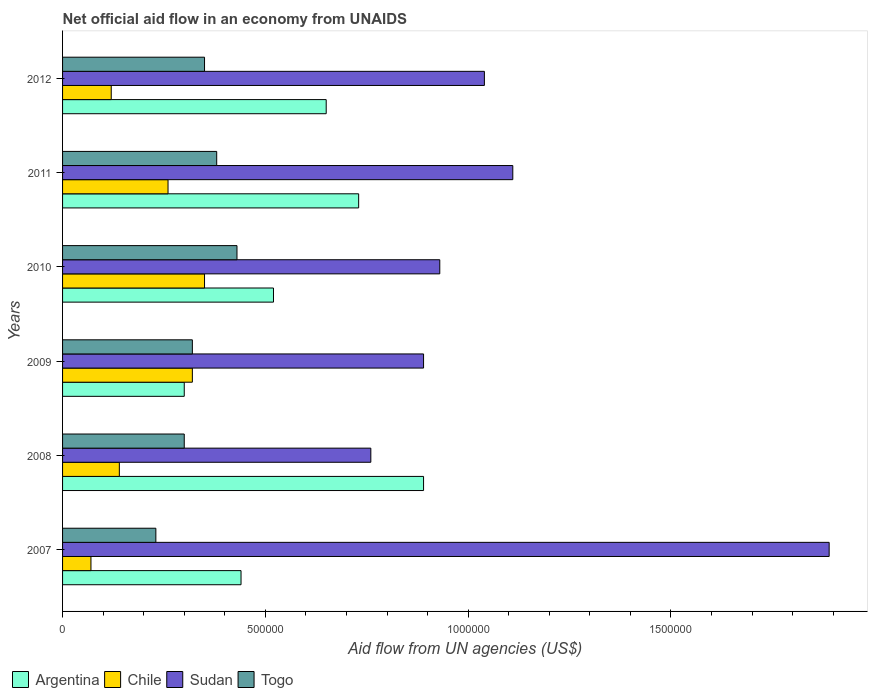How many different coloured bars are there?
Offer a very short reply. 4. Are the number of bars per tick equal to the number of legend labels?
Your answer should be compact. Yes. Are the number of bars on each tick of the Y-axis equal?
Keep it short and to the point. Yes. What is the net official aid flow in Chile in 2011?
Your answer should be compact. 2.60e+05. Across all years, what is the maximum net official aid flow in Argentina?
Ensure brevity in your answer.  8.90e+05. Across all years, what is the minimum net official aid flow in Sudan?
Provide a succinct answer. 7.60e+05. In which year was the net official aid flow in Togo maximum?
Your answer should be very brief. 2010. What is the total net official aid flow in Togo in the graph?
Keep it short and to the point. 2.01e+06. What is the difference between the net official aid flow in Argentina in 2009 and that in 2012?
Keep it short and to the point. -3.50e+05. What is the difference between the net official aid flow in Togo in 2007 and the net official aid flow in Chile in 2012?
Your answer should be very brief. 1.10e+05. What is the average net official aid flow in Sudan per year?
Offer a terse response. 1.10e+06. In the year 2011, what is the difference between the net official aid flow in Togo and net official aid flow in Chile?
Keep it short and to the point. 1.20e+05. In how many years, is the net official aid flow in Sudan greater than 1600000 US$?
Make the answer very short. 1. What is the ratio of the net official aid flow in Togo in 2007 to that in 2009?
Your answer should be very brief. 0.72. Is the difference between the net official aid flow in Togo in 2010 and 2011 greater than the difference between the net official aid flow in Chile in 2010 and 2011?
Make the answer very short. No. What is the difference between the highest and the second highest net official aid flow in Argentina?
Offer a terse response. 1.60e+05. What is the difference between the highest and the lowest net official aid flow in Chile?
Keep it short and to the point. 2.80e+05. In how many years, is the net official aid flow in Argentina greater than the average net official aid flow in Argentina taken over all years?
Your answer should be very brief. 3. Is the sum of the net official aid flow in Togo in 2009 and 2011 greater than the maximum net official aid flow in Sudan across all years?
Provide a succinct answer. No. What does the 2nd bar from the top in 2011 represents?
Provide a short and direct response. Sudan. What does the 3rd bar from the bottom in 2010 represents?
Give a very brief answer. Sudan. Is it the case that in every year, the sum of the net official aid flow in Chile and net official aid flow in Togo is greater than the net official aid flow in Argentina?
Your answer should be very brief. No. How many bars are there?
Provide a succinct answer. 24. Are all the bars in the graph horizontal?
Keep it short and to the point. Yes. How many years are there in the graph?
Your answer should be very brief. 6. What is the difference between two consecutive major ticks on the X-axis?
Provide a succinct answer. 5.00e+05. Where does the legend appear in the graph?
Provide a succinct answer. Bottom left. What is the title of the graph?
Keep it short and to the point. Net official aid flow in an economy from UNAIDS. What is the label or title of the X-axis?
Provide a short and direct response. Aid flow from UN agencies (US$). What is the label or title of the Y-axis?
Ensure brevity in your answer.  Years. What is the Aid flow from UN agencies (US$) of Sudan in 2007?
Your answer should be very brief. 1.89e+06. What is the Aid flow from UN agencies (US$) of Togo in 2007?
Your answer should be very brief. 2.30e+05. What is the Aid flow from UN agencies (US$) in Argentina in 2008?
Offer a very short reply. 8.90e+05. What is the Aid flow from UN agencies (US$) in Sudan in 2008?
Offer a terse response. 7.60e+05. What is the Aid flow from UN agencies (US$) of Togo in 2008?
Provide a short and direct response. 3.00e+05. What is the Aid flow from UN agencies (US$) of Chile in 2009?
Your answer should be very brief. 3.20e+05. What is the Aid flow from UN agencies (US$) in Sudan in 2009?
Offer a terse response. 8.90e+05. What is the Aid flow from UN agencies (US$) of Togo in 2009?
Provide a short and direct response. 3.20e+05. What is the Aid flow from UN agencies (US$) of Argentina in 2010?
Offer a very short reply. 5.20e+05. What is the Aid flow from UN agencies (US$) of Chile in 2010?
Give a very brief answer. 3.50e+05. What is the Aid flow from UN agencies (US$) of Sudan in 2010?
Offer a terse response. 9.30e+05. What is the Aid flow from UN agencies (US$) in Argentina in 2011?
Keep it short and to the point. 7.30e+05. What is the Aid flow from UN agencies (US$) in Chile in 2011?
Ensure brevity in your answer.  2.60e+05. What is the Aid flow from UN agencies (US$) of Sudan in 2011?
Provide a short and direct response. 1.11e+06. What is the Aid flow from UN agencies (US$) of Argentina in 2012?
Offer a terse response. 6.50e+05. What is the Aid flow from UN agencies (US$) of Chile in 2012?
Ensure brevity in your answer.  1.20e+05. What is the Aid flow from UN agencies (US$) in Sudan in 2012?
Keep it short and to the point. 1.04e+06. What is the Aid flow from UN agencies (US$) in Togo in 2012?
Provide a short and direct response. 3.50e+05. Across all years, what is the maximum Aid flow from UN agencies (US$) of Argentina?
Offer a very short reply. 8.90e+05. Across all years, what is the maximum Aid flow from UN agencies (US$) in Sudan?
Make the answer very short. 1.89e+06. Across all years, what is the minimum Aid flow from UN agencies (US$) in Argentina?
Provide a succinct answer. 3.00e+05. Across all years, what is the minimum Aid flow from UN agencies (US$) in Sudan?
Your answer should be compact. 7.60e+05. Across all years, what is the minimum Aid flow from UN agencies (US$) of Togo?
Keep it short and to the point. 2.30e+05. What is the total Aid flow from UN agencies (US$) in Argentina in the graph?
Offer a terse response. 3.53e+06. What is the total Aid flow from UN agencies (US$) of Chile in the graph?
Ensure brevity in your answer.  1.26e+06. What is the total Aid flow from UN agencies (US$) of Sudan in the graph?
Provide a succinct answer. 6.62e+06. What is the total Aid flow from UN agencies (US$) of Togo in the graph?
Provide a short and direct response. 2.01e+06. What is the difference between the Aid flow from UN agencies (US$) in Argentina in 2007 and that in 2008?
Your response must be concise. -4.50e+05. What is the difference between the Aid flow from UN agencies (US$) in Sudan in 2007 and that in 2008?
Make the answer very short. 1.13e+06. What is the difference between the Aid flow from UN agencies (US$) in Argentina in 2007 and that in 2009?
Give a very brief answer. 1.40e+05. What is the difference between the Aid flow from UN agencies (US$) of Sudan in 2007 and that in 2009?
Your answer should be compact. 1.00e+06. What is the difference between the Aid flow from UN agencies (US$) in Togo in 2007 and that in 2009?
Your response must be concise. -9.00e+04. What is the difference between the Aid flow from UN agencies (US$) in Argentina in 2007 and that in 2010?
Offer a terse response. -8.00e+04. What is the difference between the Aid flow from UN agencies (US$) in Chile in 2007 and that in 2010?
Offer a very short reply. -2.80e+05. What is the difference between the Aid flow from UN agencies (US$) in Sudan in 2007 and that in 2010?
Keep it short and to the point. 9.60e+05. What is the difference between the Aid flow from UN agencies (US$) in Argentina in 2007 and that in 2011?
Keep it short and to the point. -2.90e+05. What is the difference between the Aid flow from UN agencies (US$) in Sudan in 2007 and that in 2011?
Ensure brevity in your answer.  7.80e+05. What is the difference between the Aid flow from UN agencies (US$) in Togo in 2007 and that in 2011?
Make the answer very short. -1.50e+05. What is the difference between the Aid flow from UN agencies (US$) in Sudan in 2007 and that in 2012?
Ensure brevity in your answer.  8.50e+05. What is the difference between the Aid flow from UN agencies (US$) in Togo in 2007 and that in 2012?
Keep it short and to the point. -1.20e+05. What is the difference between the Aid flow from UN agencies (US$) of Argentina in 2008 and that in 2009?
Your answer should be very brief. 5.90e+05. What is the difference between the Aid flow from UN agencies (US$) in Sudan in 2008 and that in 2009?
Your answer should be compact. -1.30e+05. What is the difference between the Aid flow from UN agencies (US$) in Togo in 2008 and that in 2009?
Give a very brief answer. -2.00e+04. What is the difference between the Aid flow from UN agencies (US$) of Argentina in 2008 and that in 2011?
Provide a succinct answer. 1.60e+05. What is the difference between the Aid flow from UN agencies (US$) in Sudan in 2008 and that in 2011?
Offer a terse response. -3.50e+05. What is the difference between the Aid flow from UN agencies (US$) of Argentina in 2008 and that in 2012?
Make the answer very short. 2.40e+05. What is the difference between the Aid flow from UN agencies (US$) of Sudan in 2008 and that in 2012?
Make the answer very short. -2.80e+05. What is the difference between the Aid flow from UN agencies (US$) of Argentina in 2009 and that in 2010?
Make the answer very short. -2.20e+05. What is the difference between the Aid flow from UN agencies (US$) of Sudan in 2009 and that in 2010?
Your answer should be compact. -4.00e+04. What is the difference between the Aid flow from UN agencies (US$) in Argentina in 2009 and that in 2011?
Ensure brevity in your answer.  -4.30e+05. What is the difference between the Aid flow from UN agencies (US$) of Sudan in 2009 and that in 2011?
Make the answer very short. -2.20e+05. What is the difference between the Aid flow from UN agencies (US$) of Togo in 2009 and that in 2011?
Offer a terse response. -6.00e+04. What is the difference between the Aid flow from UN agencies (US$) in Argentina in 2009 and that in 2012?
Offer a terse response. -3.50e+05. What is the difference between the Aid flow from UN agencies (US$) in Chile in 2009 and that in 2012?
Keep it short and to the point. 2.00e+05. What is the difference between the Aid flow from UN agencies (US$) in Sudan in 2009 and that in 2012?
Provide a short and direct response. -1.50e+05. What is the difference between the Aid flow from UN agencies (US$) of Chile in 2010 and that in 2011?
Offer a very short reply. 9.00e+04. What is the difference between the Aid flow from UN agencies (US$) in Sudan in 2010 and that in 2011?
Give a very brief answer. -1.80e+05. What is the difference between the Aid flow from UN agencies (US$) of Togo in 2010 and that in 2011?
Your answer should be very brief. 5.00e+04. What is the difference between the Aid flow from UN agencies (US$) in Chile in 2010 and that in 2012?
Keep it short and to the point. 2.30e+05. What is the difference between the Aid flow from UN agencies (US$) of Sudan in 2010 and that in 2012?
Ensure brevity in your answer.  -1.10e+05. What is the difference between the Aid flow from UN agencies (US$) in Sudan in 2011 and that in 2012?
Offer a terse response. 7.00e+04. What is the difference between the Aid flow from UN agencies (US$) in Togo in 2011 and that in 2012?
Offer a terse response. 3.00e+04. What is the difference between the Aid flow from UN agencies (US$) of Argentina in 2007 and the Aid flow from UN agencies (US$) of Chile in 2008?
Provide a short and direct response. 3.00e+05. What is the difference between the Aid flow from UN agencies (US$) in Argentina in 2007 and the Aid flow from UN agencies (US$) in Sudan in 2008?
Give a very brief answer. -3.20e+05. What is the difference between the Aid flow from UN agencies (US$) of Chile in 2007 and the Aid flow from UN agencies (US$) of Sudan in 2008?
Your answer should be very brief. -6.90e+05. What is the difference between the Aid flow from UN agencies (US$) of Sudan in 2007 and the Aid flow from UN agencies (US$) of Togo in 2008?
Provide a short and direct response. 1.59e+06. What is the difference between the Aid flow from UN agencies (US$) in Argentina in 2007 and the Aid flow from UN agencies (US$) in Chile in 2009?
Provide a succinct answer. 1.20e+05. What is the difference between the Aid flow from UN agencies (US$) in Argentina in 2007 and the Aid flow from UN agencies (US$) in Sudan in 2009?
Offer a very short reply. -4.50e+05. What is the difference between the Aid flow from UN agencies (US$) of Chile in 2007 and the Aid flow from UN agencies (US$) of Sudan in 2009?
Keep it short and to the point. -8.20e+05. What is the difference between the Aid flow from UN agencies (US$) in Chile in 2007 and the Aid flow from UN agencies (US$) in Togo in 2009?
Ensure brevity in your answer.  -2.50e+05. What is the difference between the Aid flow from UN agencies (US$) in Sudan in 2007 and the Aid flow from UN agencies (US$) in Togo in 2009?
Offer a very short reply. 1.57e+06. What is the difference between the Aid flow from UN agencies (US$) of Argentina in 2007 and the Aid flow from UN agencies (US$) of Sudan in 2010?
Ensure brevity in your answer.  -4.90e+05. What is the difference between the Aid flow from UN agencies (US$) in Argentina in 2007 and the Aid flow from UN agencies (US$) in Togo in 2010?
Provide a short and direct response. 10000. What is the difference between the Aid flow from UN agencies (US$) in Chile in 2007 and the Aid flow from UN agencies (US$) in Sudan in 2010?
Offer a terse response. -8.60e+05. What is the difference between the Aid flow from UN agencies (US$) of Chile in 2007 and the Aid flow from UN agencies (US$) of Togo in 2010?
Make the answer very short. -3.60e+05. What is the difference between the Aid flow from UN agencies (US$) in Sudan in 2007 and the Aid flow from UN agencies (US$) in Togo in 2010?
Your answer should be very brief. 1.46e+06. What is the difference between the Aid flow from UN agencies (US$) of Argentina in 2007 and the Aid flow from UN agencies (US$) of Sudan in 2011?
Your response must be concise. -6.70e+05. What is the difference between the Aid flow from UN agencies (US$) in Argentina in 2007 and the Aid flow from UN agencies (US$) in Togo in 2011?
Your answer should be compact. 6.00e+04. What is the difference between the Aid flow from UN agencies (US$) of Chile in 2007 and the Aid flow from UN agencies (US$) of Sudan in 2011?
Keep it short and to the point. -1.04e+06. What is the difference between the Aid flow from UN agencies (US$) of Chile in 2007 and the Aid flow from UN agencies (US$) of Togo in 2011?
Your answer should be compact. -3.10e+05. What is the difference between the Aid flow from UN agencies (US$) in Sudan in 2007 and the Aid flow from UN agencies (US$) in Togo in 2011?
Offer a terse response. 1.51e+06. What is the difference between the Aid flow from UN agencies (US$) in Argentina in 2007 and the Aid flow from UN agencies (US$) in Sudan in 2012?
Offer a terse response. -6.00e+05. What is the difference between the Aid flow from UN agencies (US$) of Argentina in 2007 and the Aid flow from UN agencies (US$) of Togo in 2012?
Make the answer very short. 9.00e+04. What is the difference between the Aid flow from UN agencies (US$) in Chile in 2007 and the Aid flow from UN agencies (US$) in Sudan in 2012?
Your response must be concise. -9.70e+05. What is the difference between the Aid flow from UN agencies (US$) of Chile in 2007 and the Aid flow from UN agencies (US$) of Togo in 2012?
Give a very brief answer. -2.80e+05. What is the difference between the Aid flow from UN agencies (US$) of Sudan in 2007 and the Aid flow from UN agencies (US$) of Togo in 2012?
Keep it short and to the point. 1.54e+06. What is the difference between the Aid flow from UN agencies (US$) of Argentina in 2008 and the Aid flow from UN agencies (US$) of Chile in 2009?
Give a very brief answer. 5.70e+05. What is the difference between the Aid flow from UN agencies (US$) of Argentina in 2008 and the Aid flow from UN agencies (US$) of Togo in 2009?
Offer a very short reply. 5.70e+05. What is the difference between the Aid flow from UN agencies (US$) in Chile in 2008 and the Aid flow from UN agencies (US$) in Sudan in 2009?
Offer a terse response. -7.50e+05. What is the difference between the Aid flow from UN agencies (US$) in Chile in 2008 and the Aid flow from UN agencies (US$) in Togo in 2009?
Your answer should be very brief. -1.80e+05. What is the difference between the Aid flow from UN agencies (US$) in Argentina in 2008 and the Aid flow from UN agencies (US$) in Chile in 2010?
Give a very brief answer. 5.40e+05. What is the difference between the Aid flow from UN agencies (US$) of Argentina in 2008 and the Aid flow from UN agencies (US$) of Sudan in 2010?
Make the answer very short. -4.00e+04. What is the difference between the Aid flow from UN agencies (US$) in Chile in 2008 and the Aid flow from UN agencies (US$) in Sudan in 2010?
Ensure brevity in your answer.  -7.90e+05. What is the difference between the Aid flow from UN agencies (US$) of Argentina in 2008 and the Aid flow from UN agencies (US$) of Chile in 2011?
Provide a succinct answer. 6.30e+05. What is the difference between the Aid flow from UN agencies (US$) of Argentina in 2008 and the Aid flow from UN agencies (US$) of Sudan in 2011?
Offer a very short reply. -2.20e+05. What is the difference between the Aid flow from UN agencies (US$) in Argentina in 2008 and the Aid flow from UN agencies (US$) in Togo in 2011?
Your response must be concise. 5.10e+05. What is the difference between the Aid flow from UN agencies (US$) in Chile in 2008 and the Aid flow from UN agencies (US$) in Sudan in 2011?
Provide a succinct answer. -9.70e+05. What is the difference between the Aid flow from UN agencies (US$) in Argentina in 2008 and the Aid flow from UN agencies (US$) in Chile in 2012?
Offer a terse response. 7.70e+05. What is the difference between the Aid flow from UN agencies (US$) of Argentina in 2008 and the Aid flow from UN agencies (US$) of Togo in 2012?
Provide a succinct answer. 5.40e+05. What is the difference between the Aid flow from UN agencies (US$) of Chile in 2008 and the Aid flow from UN agencies (US$) of Sudan in 2012?
Keep it short and to the point. -9.00e+05. What is the difference between the Aid flow from UN agencies (US$) of Chile in 2008 and the Aid flow from UN agencies (US$) of Togo in 2012?
Give a very brief answer. -2.10e+05. What is the difference between the Aid flow from UN agencies (US$) of Argentina in 2009 and the Aid flow from UN agencies (US$) of Chile in 2010?
Offer a very short reply. -5.00e+04. What is the difference between the Aid flow from UN agencies (US$) of Argentina in 2009 and the Aid flow from UN agencies (US$) of Sudan in 2010?
Provide a succinct answer. -6.30e+05. What is the difference between the Aid flow from UN agencies (US$) in Chile in 2009 and the Aid flow from UN agencies (US$) in Sudan in 2010?
Make the answer very short. -6.10e+05. What is the difference between the Aid flow from UN agencies (US$) in Chile in 2009 and the Aid flow from UN agencies (US$) in Togo in 2010?
Keep it short and to the point. -1.10e+05. What is the difference between the Aid flow from UN agencies (US$) of Argentina in 2009 and the Aid flow from UN agencies (US$) of Sudan in 2011?
Make the answer very short. -8.10e+05. What is the difference between the Aid flow from UN agencies (US$) of Chile in 2009 and the Aid flow from UN agencies (US$) of Sudan in 2011?
Keep it short and to the point. -7.90e+05. What is the difference between the Aid flow from UN agencies (US$) in Chile in 2009 and the Aid flow from UN agencies (US$) in Togo in 2011?
Offer a very short reply. -6.00e+04. What is the difference between the Aid flow from UN agencies (US$) of Sudan in 2009 and the Aid flow from UN agencies (US$) of Togo in 2011?
Your answer should be compact. 5.10e+05. What is the difference between the Aid flow from UN agencies (US$) of Argentina in 2009 and the Aid flow from UN agencies (US$) of Sudan in 2012?
Your answer should be very brief. -7.40e+05. What is the difference between the Aid flow from UN agencies (US$) of Chile in 2009 and the Aid flow from UN agencies (US$) of Sudan in 2012?
Offer a very short reply. -7.20e+05. What is the difference between the Aid flow from UN agencies (US$) in Chile in 2009 and the Aid flow from UN agencies (US$) in Togo in 2012?
Give a very brief answer. -3.00e+04. What is the difference between the Aid flow from UN agencies (US$) in Sudan in 2009 and the Aid flow from UN agencies (US$) in Togo in 2012?
Keep it short and to the point. 5.40e+05. What is the difference between the Aid flow from UN agencies (US$) in Argentina in 2010 and the Aid flow from UN agencies (US$) in Sudan in 2011?
Provide a succinct answer. -5.90e+05. What is the difference between the Aid flow from UN agencies (US$) of Argentina in 2010 and the Aid flow from UN agencies (US$) of Togo in 2011?
Your response must be concise. 1.40e+05. What is the difference between the Aid flow from UN agencies (US$) in Chile in 2010 and the Aid flow from UN agencies (US$) in Sudan in 2011?
Offer a terse response. -7.60e+05. What is the difference between the Aid flow from UN agencies (US$) of Chile in 2010 and the Aid flow from UN agencies (US$) of Togo in 2011?
Provide a short and direct response. -3.00e+04. What is the difference between the Aid flow from UN agencies (US$) in Argentina in 2010 and the Aid flow from UN agencies (US$) in Chile in 2012?
Your answer should be compact. 4.00e+05. What is the difference between the Aid flow from UN agencies (US$) of Argentina in 2010 and the Aid flow from UN agencies (US$) of Sudan in 2012?
Offer a terse response. -5.20e+05. What is the difference between the Aid flow from UN agencies (US$) of Argentina in 2010 and the Aid flow from UN agencies (US$) of Togo in 2012?
Ensure brevity in your answer.  1.70e+05. What is the difference between the Aid flow from UN agencies (US$) of Chile in 2010 and the Aid flow from UN agencies (US$) of Sudan in 2012?
Offer a very short reply. -6.90e+05. What is the difference between the Aid flow from UN agencies (US$) of Sudan in 2010 and the Aid flow from UN agencies (US$) of Togo in 2012?
Make the answer very short. 5.80e+05. What is the difference between the Aid flow from UN agencies (US$) of Argentina in 2011 and the Aid flow from UN agencies (US$) of Chile in 2012?
Your response must be concise. 6.10e+05. What is the difference between the Aid flow from UN agencies (US$) in Argentina in 2011 and the Aid flow from UN agencies (US$) in Sudan in 2012?
Make the answer very short. -3.10e+05. What is the difference between the Aid flow from UN agencies (US$) of Argentina in 2011 and the Aid flow from UN agencies (US$) of Togo in 2012?
Offer a terse response. 3.80e+05. What is the difference between the Aid flow from UN agencies (US$) of Chile in 2011 and the Aid flow from UN agencies (US$) of Sudan in 2012?
Your answer should be very brief. -7.80e+05. What is the difference between the Aid flow from UN agencies (US$) of Sudan in 2011 and the Aid flow from UN agencies (US$) of Togo in 2012?
Your answer should be compact. 7.60e+05. What is the average Aid flow from UN agencies (US$) in Argentina per year?
Give a very brief answer. 5.88e+05. What is the average Aid flow from UN agencies (US$) in Sudan per year?
Offer a very short reply. 1.10e+06. What is the average Aid flow from UN agencies (US$) of Togo per year?
Your response must be concise. 3.35e+05. In the year 2007, what is the difference between the Aid flow from UN agencies (US$) of Argentina and Aid flow from UN agencies (US$) of Sudan?
Offer a very short reply. -1.45e+06. In the year 2007, what is the difference between the Aid flow from UN agencies (US$) of Chile and Aid flow from UN agencies (US$) of Sudan?
Keep it short and to the point. -1.82e+06. In the year 2007, what is the difference between the Aid flow from UN agencies (US$) in Sudan and Aid flow from UN agencies (US$) in Togo?
Provide a short and direct response. 1.66e+06. In the year 2008, what is the difference between the Aid flow from UN agencies (US$) of Argentina and Aid flow from UN agencies (US$) of Chile?
Ensure brevity in your answer.  7.50e+05. In the year 2008, what is the difference between the Aid flow from UN agencies (US$) in Argentina and Aid flow from UN agencies (US$) in Togo?
Keep it short and to the point. 5.90e+05. In the year 2008, what is the difference between the Aid flow from UN agencies (US$) in Chile and Aid flow from UN agencies (US$) in Sudan?
Offer a very short reply. -6.20e+05. In the year 2008, what is the difference between the Aid flow from UN agencies (US$) in Chile and Aid flow from UN agencies (US$) in Togo?
Your response must be concise. -1.60e+05. In the year 2009, what is the difference between the Aid flow from UN agencies (US$) of Argentina and Aid flow from UN agencies (US$) of Chile?
Keep it short and to the point. -2.00e+04. In the year 2009, what is the difference between the Aid flow from UN agencies (US$) of Argentina and Aid flow from UN agencies (US$) of Sudan?
Offer a terse response. -5.90e+05. In the year 2009, what is the difference between the Aid flow from UN agencies (US$) in Argentina and Aid flow from UN agencies (US$) in Togo?
Your answer should be compact. -2.00e+04. In the year 2009, what is the difference between the Aid flow from UN agencies (US$) in Chile and Aid flow from UN agencies (US$) in Sudan?
Keep it short and to the point. -5.70e+05. In the year 2009, what is the difference between the Aid flow from UN agencies (US$) in Chile and Aid flow from UN agencies (US$) in Togo?
Provide a short and direct response. 0. In the year 2009, what is the difference between the Aid flow from UN agencies (US$) of Sudan and Aid flow from UN agencies (US$) of Togo?
Your response must be concise. 5.70e+05. In the year 2010, what is the difference between the Aid flow from UN agencies (US$) in Argentina and Aid flow from UN agencies (US$) in Chile?
Your answer should be very brief. 1.70e+05. In the year 2010, what is the difference between the Aid flow from UN agencies (US$) of Argentina and Aid flow from UN agencies (US$) of Sudan?
Offer a terse response. -4.10e+05. In the year 2010, what is the difference between the Aid flow from UN agencies (US$) of Argentina and Aid flow from UN agencies (US$) of Togo?
Your response must be concise. 9.00e+04. In the year 2010, what is the difference between the Aid flow from UN agencies (US$) in Chile and Aid flow from UN agencies (US$) in Sudan?
Keep it short and to the point. -5.80e+05. In the year 2010, what is the difference between the Aid flow from UN agencies (US$) in Sudan and Aid flow from UN agencies (US$) in Togo?
Your response must be concise. 5.00e+05. In the year 2011, what is the difference between the Aid flow from UN agencies (US$) of Argentina and Aid flow from UN agencies (US$) of Sudan?
Provide a succinct answer. -3.80e+05. In the year 2011, what is the difference between the Aid flow from UN agencies (US$) in Chile and Aid flow from UN agencies (US$) in Sudan?
Ensure brevity in your answer.  -8.50e+05. In the year 2011, what is the difference between the Aid flow from UN agencies (US$) of Sudan and Aid flow from UN agencies (US$) of Togo?
Your answer should be very brief. 7.30e+05. In the year 2012, what is the difference between the Aid flow from UN agencies (US$) in Argentina and Aid flow from UN agencies (US$) in Chile?
Make the answer very short. 5.30e+05. In the year 2012, what is the difference between the Aid flow from UN agencies (US$) of Argentina and Aid flow from UN agencies (US$) of Sudan?
Make the answer very short. -3.90e+05. In the year 2012, what is the difference between the Aid flow from UN agencies (US$) in Argentina and Aid flow from UN agencies (US$) in Togo?
Provide a short and direct response. 3.00e+05. In the year 2012, what is the difference between the Aid flow from UN agencies (US$) of Chile and Aid flow from UN agencies (US$) of Sudan?
Keep it short and to the point. -9.20e+05. In the year 2012, what is the difference between the Aid flow from UN agencies (US$) of Chile and Aid flow from UN agencies (US$) of Togo?
Provide a short and direct response. -2.30e+05. In the year 2012, what is the difference between the Aid flow from UN agencies (US$) in Sudan and Aid flow from UN agencies (US$) in Togo?
Provide a succinct answer. 6.90e+05. What is the ratio of the Aid flow from UN agencies (US$) of Argentina in 2007 to that in 2008?
Offer a very short reply. 0.49. What is the ratio of the Aid flow from UN agencies (US$) in Chile in 2007 to that in 2008?
Provide a succinct answer. 0.5. What is the ratio of the Aid flow from UN agencies (US$) of Sudan in 2007 to that in 2008?
Ensure brevity in your answer.  2.49. What is the ratio of the Aid flow from UN agencies (US$) of Togo in 2007 to that in 2008?
Your response must be concise. 0.77. What is the ratio of the Aid flow from UN agencies (US$) in Argentina in 2007 to that in 2009?
Your answer should be very brief. 1.47. What is the ratio of the Aid flow from UN agencies (US$) in Chile in 2007 to that in 2009?
Give a very brief answer. 0.22. What is the ratio of the Aid flow from UN agencies (US$) of Sudan in 2007 to that in 2009?
Your response must be concise. 2.12. What is the ratio of the Aid flow from UN agencies (US$) in Togo in 2007 to that in 2009?
Your response must be concise. 0.72. What is the ratio of the Aid flow from UN agencies (US$) of Argentina in 2007 to that in 2010?
Provide a short and direct response. 0.85. What is the ratio of the Aid flow from UN agencies (US$) in Sudan in 2007 to that in 2010?
Keep it short and to the point. 2.03. What is the ratio of the Aid flow from UN agencies (US$) of Togo in 2007 to that in 2010?
Offer a very short reply. 0.53. What is the ratio of the Aid flow from UN agencies (US$) of Argentina in 2007 to that in 2011?
Your answer should be compact. 0.6. What is the ratio of the Aid flow from UN agencies (US$) in Chile in 2007 to that in 2011?
Give a very brief answer. 0.27. What is the ratio of the Aid flow from UN agencies (US$) in Sudan in 2007 to that in 2011?
Your response must be concise. 1.7. What is the ratio of the Aid flow from UN agencies (US$) in Togo in 2007 to that in 2011?
Provide a short and direct response. 0.61. What is the ratio of the Aid flow from UN agencies (US$) in Argentina in 2007 to that in 2012?
Offer a very short reply. 0.68. What is the ratio of the Aid flow from UN agencies (US$) in Chile in 2007 to that in 2012?
Ensure brevity in your answer.  0.58. What is the ratio of the Aid flow from UN agencies (US$) of Sudan in 2007 to that in 2012?
Your answer should be compact. 1.82. What is the ratio of the Aid flow from UN agencies (US$) in Togo in 2007 to that in 2012?
Your answer should be very brief. 0.66. What is the ratio of the Aid flow from UN agencies (US$) of Argentina in 2008 to that in 2009?
Make the answer very short. 2.97. What is the ratio of the Aid flow from UN agencies (US$) in Chile in 2008 to that in 2009?
Your response must be concise. 0.44. What is the ratio of the Aid flow from UN agencies (US$) of Sudan in 2008 to that in 2009?
Your response must be concise. 0.85. What is the ratio of the Aid flow from UN agencies (US$) in Argentina in 2008 to that in 2010?
Offer a terse response. 1.71. What is the ratio of the Aid flow from UN agencies (US$) in Sudan in 2008 to that in 2010?
Give a very brief answer. 0.82. What is the ratio of the Aid flow from UN agencies (US$) in Togo in 2008 to that in 2010?
Your answer should be compact. 0.7. What is the ratio of the Aid flow from UN agencies (US$) in Argentina in 2008 to that in 2011?
Provide a succinct answer. 1.22. What is the ratio of the Aid flow from UN agencies (US$) of Chile in 2008 to that in 2011?
Give a very brief answer. 0.54. What is the ratio of the Aid flow from UN agencies (US$) of Sudan in 2008 to that in 2011?
Ensure brevity in your answer.  0.68. What is the ratio of the Aid flow from UN agencies (US$) of Togo in 2008 to that in 2011?
Offer a terse response. 0.79. What is the ratio of the Aid flow from UN agencies (US$) of Argentina in 2008 to that in 2012?
Give a very brief answer. 1.37. What is the ratio of the Aid flow from UN agencies (US$) of Sudan in 2008 to that in 2012?
Your answer should be very brief. 0.73. What is the ratio of the Aid flow from UN agencies (US$) in Togo in 2008 to that in 2012?
Your answer should be very brief. 0.86. What is the ratio of the Aid flow from UN agencies (US$) in Argentina in 2009 to that in 2010?
Your answer should be very brief. 0.58. What is the ratio of the Aid flow from UN agencies (US$) in Chile in 2009 to that in 2010?
Make the answer very short. 0.91. What is the ratio of the Aid flow from UN agencies (US$) of Sudan in 2009 to that in 2010?
Give a very brief answer. 0.96. What is the ratio of the Aid flow from UN agencies (US$) of Togo in 2009 to that in 2010?
Provide a succinct answer. 0.74. What is the ratio of the Aid flow from UN agencies (US$) of Argentina in 2009 to that in 2011?
Your response must be concise. 0.41. What is the ratio of the Aid flow from UN agencies (US$) in Chile in 2009 to that in 2011?
Your response must be concise. 1.23. What is the ratio of the Aid flow from UN agencies (US$) in Sudan in 2009 to that in 2011?
Ensure brevity in your answer.  0.8. What is the ratio of the Aid flow from UN agencies (US$) in Togo in 2009 to that in 2011?
Offer a terse response. 0.84. What is the ratio of the Aid flow from UN agencies (US$) in Argentina in 2009 to that in 2012?
Give a very brief answer. 0.46. What is the ratio of the Aid flow from UN agencies (US$) in Chile in 2009 to that in 2012?
Make the answer very short. 2.67. What is the ratio of the Aid flow from UN agencies (US$) of Sudan in 2009 to that in 2012?
Keep it short and to the point. 0.86. What is the ratio of the Aid flow from UN agencies (US$) in Togo in 2009 to that in 2012?
Your response must be concise. 0.91. What is the ratio of the Aid flow from UN agencies (US$) of Argentina in 2010 to that in 2011?
Offer a very short reply. 0.71. What is the ratio of the Aid flow from UN agencies (US$) of Chile in 2010 to that in 2011?
Offer a very short reply. 1.35. What is the ratio of the Aid flow from UN agencies (US$) of Sudan in 2010 to that in 2011?
Offer a terse response. 0.84. What is the ratio of the Aid flow from UN agencies (US$) in Togo in 2010 to that in 2011?
Offer a terse response. 1.13. What is the ratio of the Aid flow from UN agencies (US$) in Argentina in 2010 to that in 2012?
Provide a succinct answer. 0.8. What is the ratio of the Aid flow from UN agencies (US$) of Chile in 2010 to that in 2012?
Provide a succinct answer. 2.92. What is the ratio of the Aid flow from UN agencies (US$) in Sudan in 2010 to that in 2012?
Your response must be concise. 0.89. What is the ratio of the Aid flow from UN agencies (US$) of Togo in 2010 to that in 2012?
Offer a very short reply. 1.23. What is the ratio of the Aid flow from UN agencies (US$) of Argentina in 2011 to that in 2012?
Your answer should be very brief. 1.12. What is the ratio of the Aid flow from UN agencies (US$) of Chile in 2011 to that in 2012?
Provide a succinct answer. 2.17. What is the ratio of the Aid flow from UN agencies (US$) of Sudan in 2011 to that in 2012?
Your answer should be very brief. 1.07. What is the ratio of the Aid flow from UN agencies (US$) of Togo in 2011 to that in 2012?
Ensure brevity in your answer.  1.09. What is the difference between the highest and the second highest Aid flow from UN agencies (US$) in Sudan?
Offer a very short reply. 7.80e+05. What is the difference between the highest and the lowest Aid flow from UN agencies (US$) of Argentina?
Your response must be concise. 5.90e+05. What is the difference between the highest and the lowest Aid flow from UN agencies (US$) in Chile?
Ensure brevity in your answer.  2.80e+05. What is the difference between the highest and the lowest Aid flow from UN agencies (US$) of Sudan?
Keep it short and to the point. 1.13e+06. What is the difference between the highest and the lowest Aid flow from UN agencies (US$) in Togo?
Your response must be concise. 2.00e+05. 